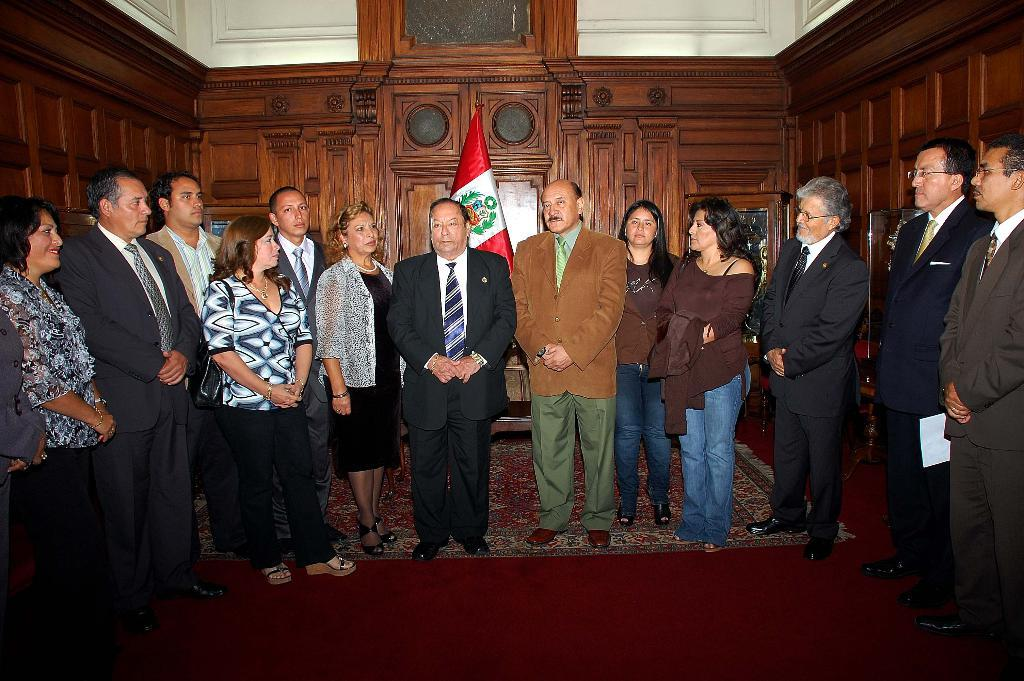What is happening in the image? There are people standing in the image. Can you describe what one of the people is holding? A man is holding a paper in his hand. What additional element can be seen in the image? There is a flag visible in the image. What type of celery is being used as a decoration in the image? There is no celery present in the image. What is the name of the downtown area visible in the image? The image does not depict a downtown area. 